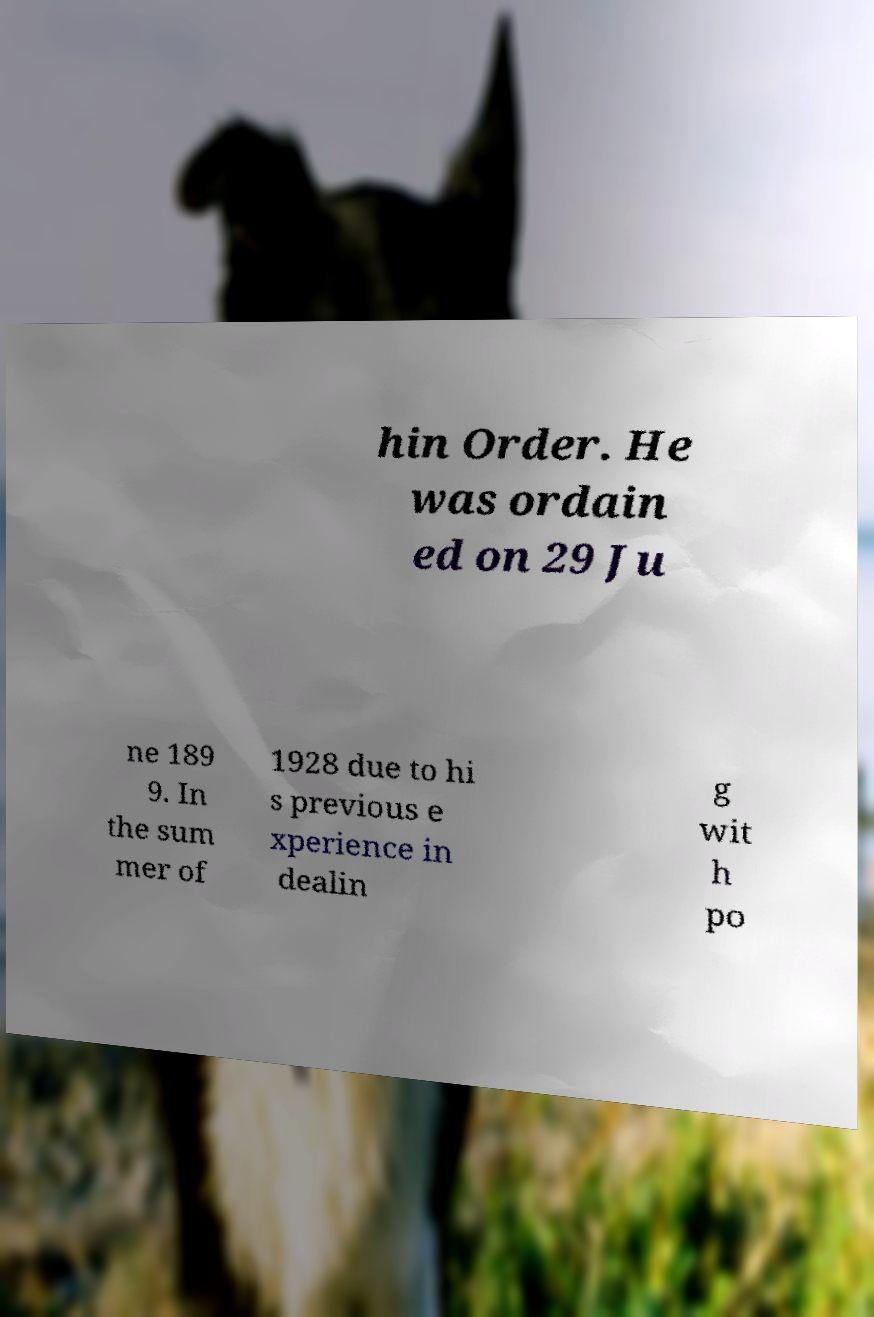Could you assist in decoding the text presented in this image and type it out clearly? hin Order. He was ordain ed on 29 Ju ne 189 9. In the sum mer of 1928 due to hi s previous e xperience in dealin g wit h po 